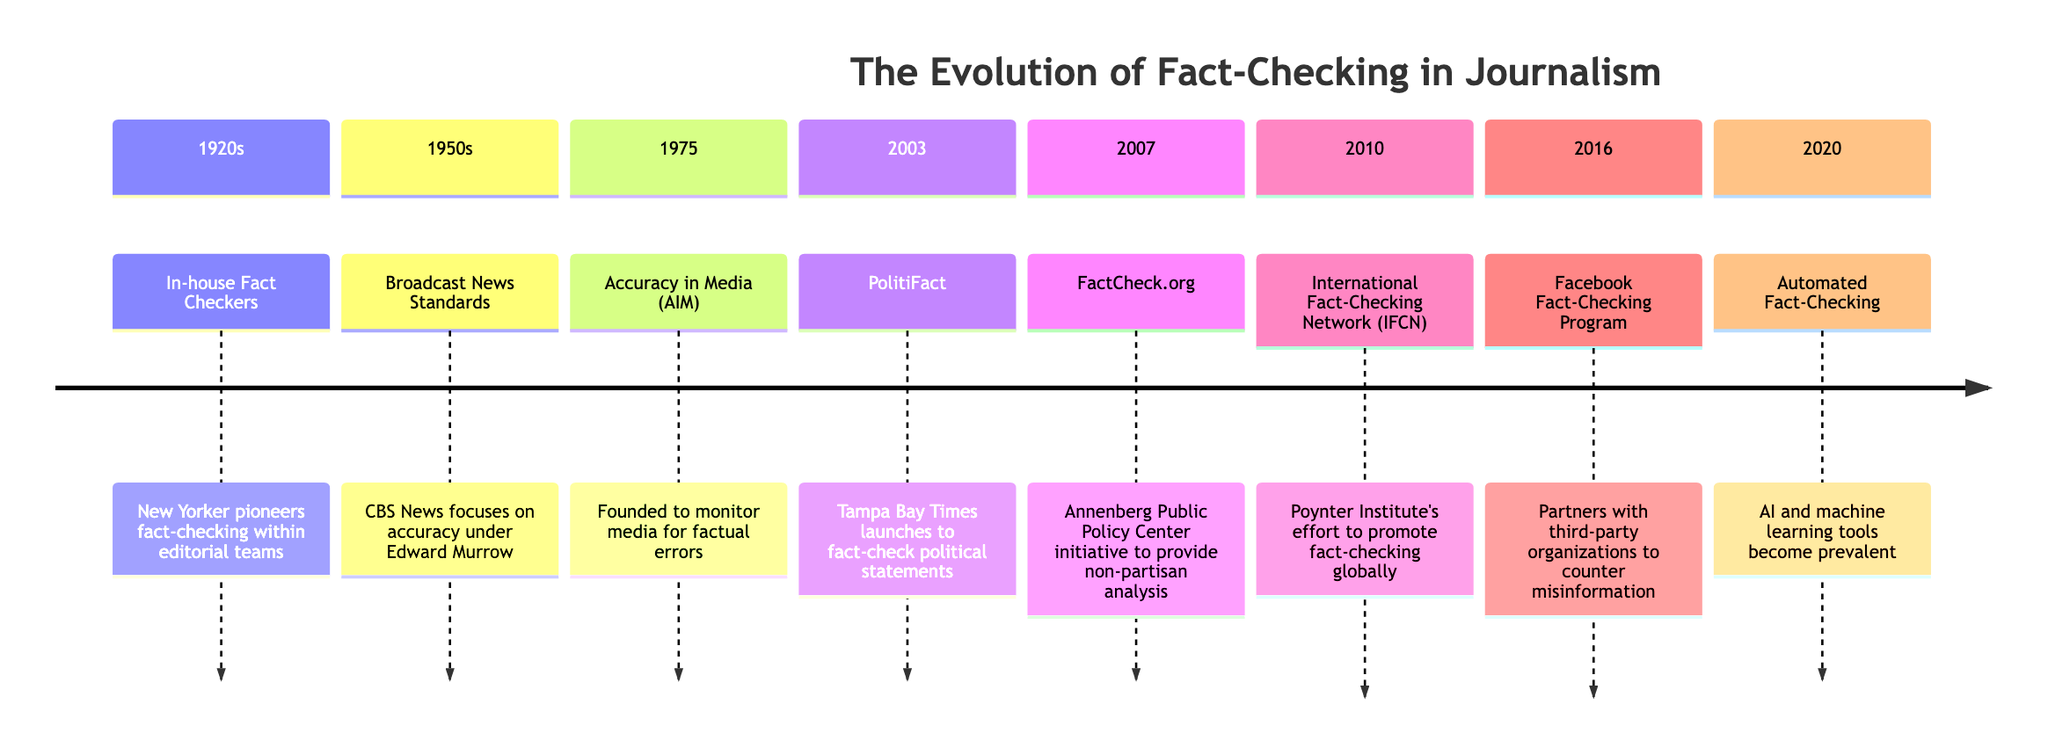What year did the New Yorker pioneer fact-checking? The diagram indicates that in the 1920s, specifically mentioning the New Yorker, fact-checking was pioneered within editorial teams. Therefore, the year associated with this milestone is 1920s.
Answer: 1920s How many significant milestones in fact-checking are listed in the timeline? By counting the sections presented in the diagram, we see there are eight key milestones from the 1920s to 2020. Thus, the total number of milestones is eight.
Answer: 8 What organization was founded in 1975 to monitor media for factual errors? Referring to the diagram, it states that in 1975, Accuracy in Media (AIM) was founded, and its purpose was to monitor the media for factual errors. Therefore, the answer is AIM.
Answer: AIM Which fact-checking initiative was launched in 2003? According to the diagram, the initiative launched in 2003 is PolitiFact, which was created by the Tampa Bay Times to fact-check political statements. Thus, the answer is PolitiFact.
Answer: PolitiFact What method became prevalent in 2020 for fact-checking? The diagram notes that in 2020, automated fact-checking became prevalent, utilizing AI and machine learning tools. Therefore, the answer is automated fact-checking.
Answer: Automated fact-checking Which milestone in the timeline corresponds with the establishment of the International Fact-Checking Network? The diagram specifies that the International Fact-Checking Network (IFCN) was established in 2010 by the Poynter Institute, so the corresponding milestone is 2010.
Answer: 2010 Which organization is noted for partnering with Facebook in 2016 for fact-checking? The diagram indicates that in 2016, Facebook implemented a fact-checking program, partnering with third-party organizations to address misinformation; thus, this initiative relates to Facebook.
Answer: Facebook What was a key focus of CBS News in the 1950s? As indicated in the diagram, the key focus of CBS News during the 1950s was on accuracy under Edward Murrow, highlighting the importance of factual reporting in broadcasting.
Answer: Accuracy 